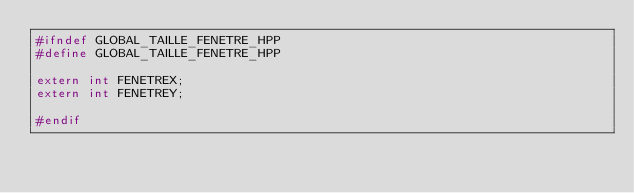<code> <loc_0><loc_0><loc_500><loc_500><_C++_>#ifndef GLOBAL_TAILLE_FENETRE_HPP
#define GLOBAL_TAILLE_FENETRE_HPP

extern int FENETREX;
extern int FENETREY;

#endif
</code> 